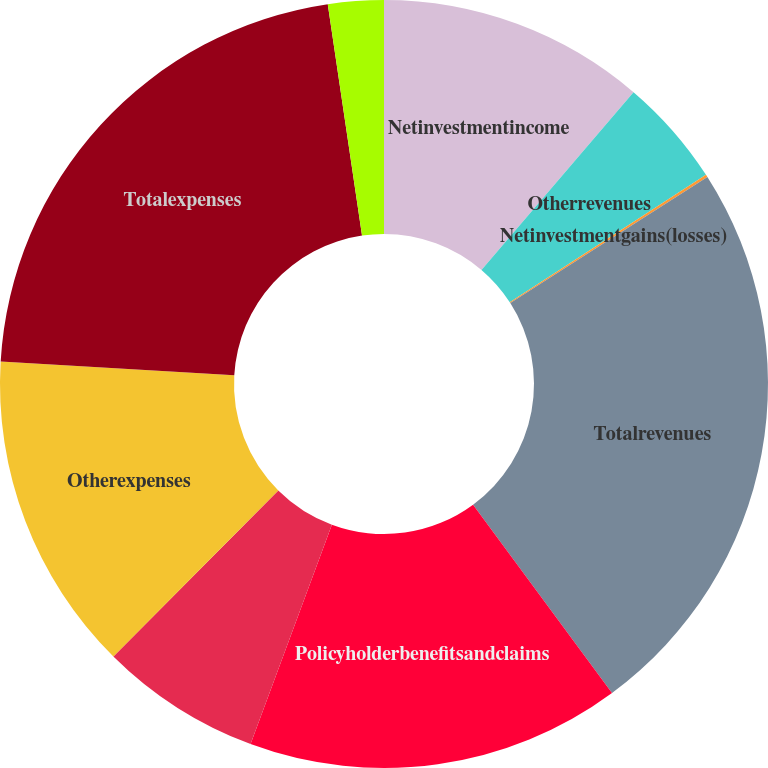Convert chart. <chart><loc_0><loc_0><loc_500><loc_500><pie_chart><fcel>Netinvestmentincome<fcel>Otherrevenues<fcel>Netinvestmentgains(losses)<fcel>Totalrevenues<fcel>Policyholderbenefitsandclaims<fcel>Unnamed: 5<fcel>Otherexpenses<fcel>Totalexpenses<fcel>Provisionforincometax<nl><fcel>11.26%<fcel>4.57%<fcel>0.11%<fcel>23.95%<fcel>15.77%<fcel>6.8%<fcel>13.49%<fcel>21.73%<fcel>2.34%<nl></chart> 